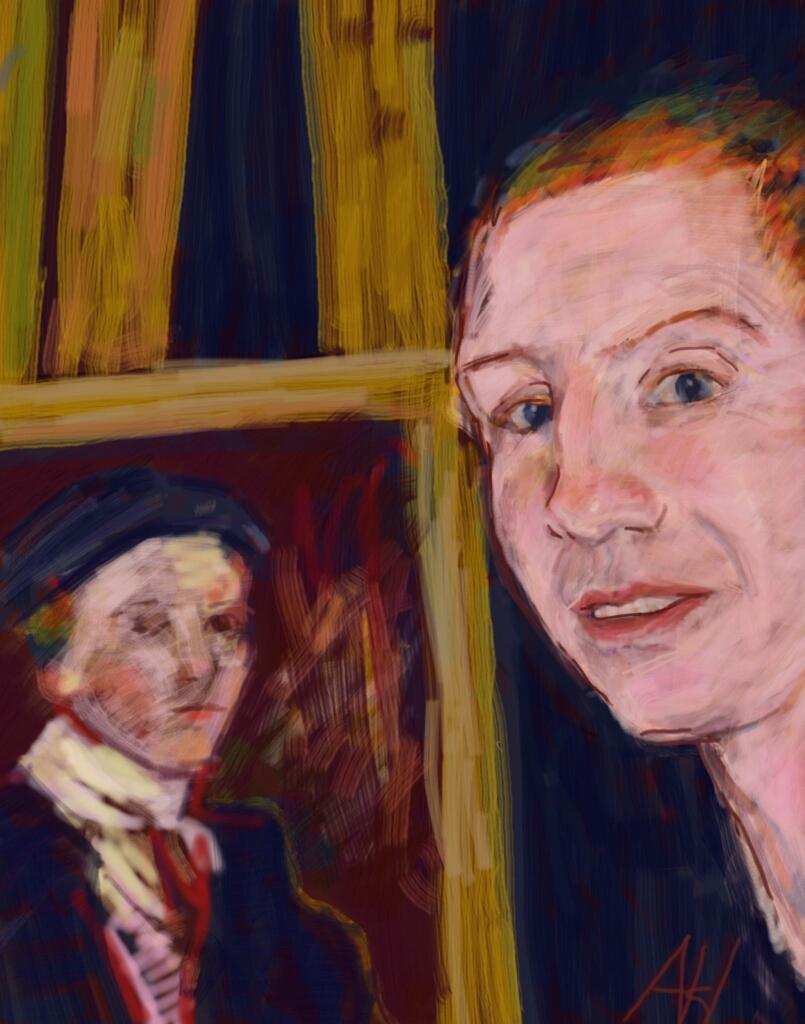Describe this image in one or two sentences. This is the painting where we can see two people. We can see bamboo poles in the background. 